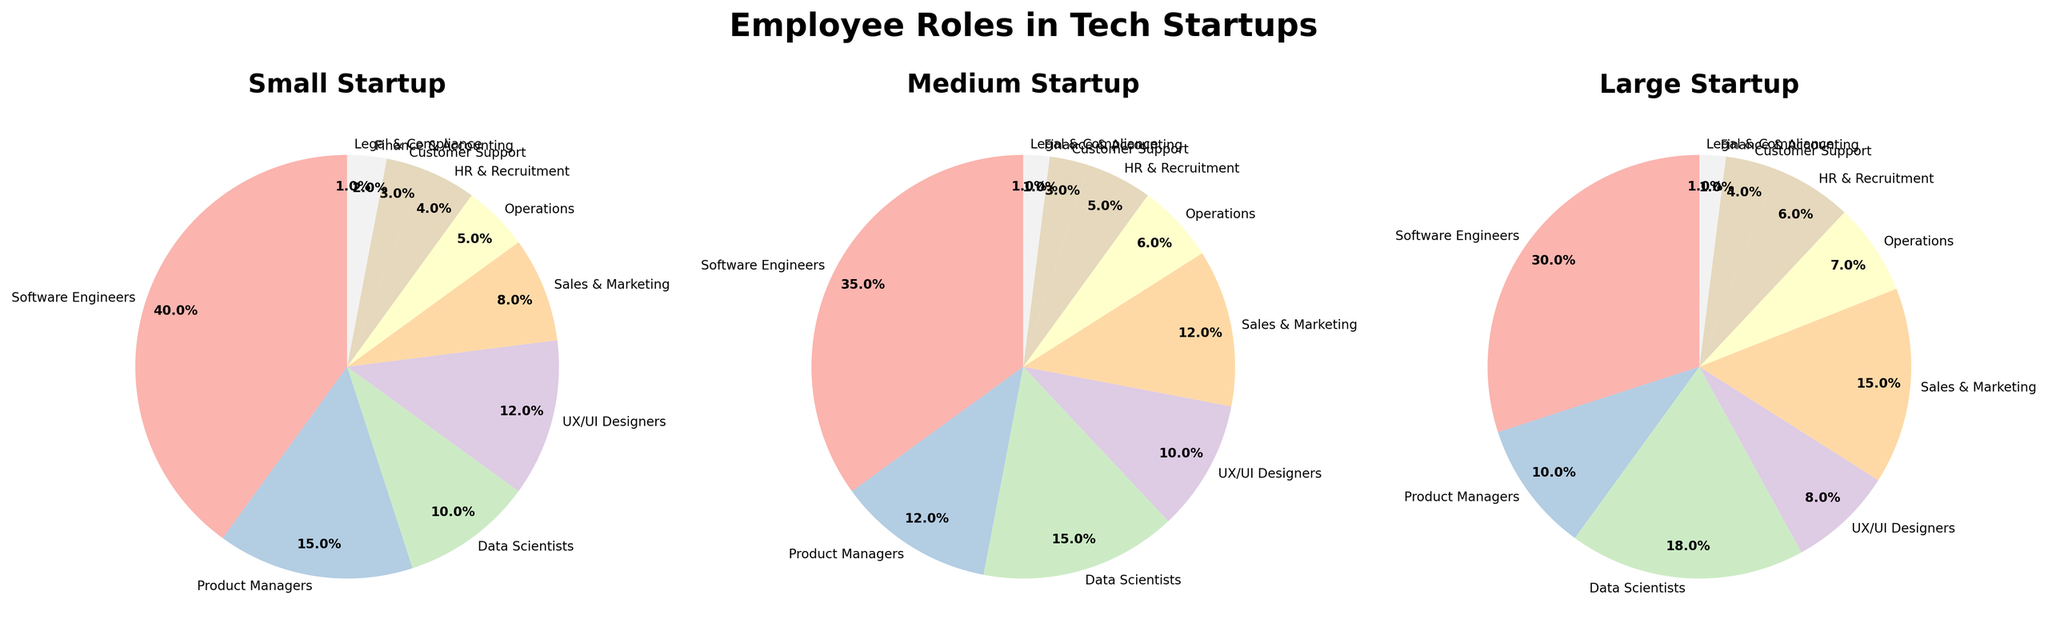What's the largest role in Small Startups? To find the largest role in Small Startups, we look at the sector of the pie chart with the largest proportion. In this chart, Software Engineers have the largest proportion among all roles.
Answer: Software Engineers What's the combined percentage of Product Managers and Data Scientists in Medium Startups? To find the combined percentage, look at the respective sectors in the pie chart for Medium Startups. Product Managers and Data Scientists have percentages of 12% and 15%, respectively. Adding these gives 12% + 15% = 27%.
Answer: 27% Which role is more prevalent in Large Startups compared to Small Startups? We need to compare the percentages of roles in Large Startups to those in Small Startups. Sales & Marketing as well as Data Scientists have higher percentages in Large Startups compared to Small Startups.
Answer: Sales & Marketing, Data Scientists Among UX/UI Designers, Operations, and HR & Recruitment in Small Startups, which has the smallest percentage? Look at the pie chart for Small Startups and identify the sectors for UX/UI Designers, Operations, and HR & Recruitment. UX/UI Designers have a percentage of 12%, Operations 5%, and HR & Recruitment 4%. Hence, HR & Recruitment has the smallest percentage.
Answer: HR & Recruitment What is the difference in percentage of Software Engineers between Small and Medium Startups? From the pie charts, Software Engineers occupy 40% in Small Startups and 35% in Medium Startups. The difference is 40% - 35% = 5%.
Answer: 5% Compare the proportion of Customer Support roles in all three startup sizes. Which startup has the lowest and which has the highest? In the pie charts, Customer Support has the following percentages: Small Startups - 3%, Medium Startups - 3%, Large Startups - 4%. Small and Medium Startups have the lowest proportion while Large Startups have the highest.
Answer: Lowest: Small & Medium, Highest: Large If you sum up the percentages of Data Scientists and UX/UI Designers in Medium Startups, would it exceed that of Software Engineers in Large Startups? Data Scientists in Medium Startups have 15% and UX/UI Designers have 10%; summing these gives 15% + 10% = 25%. Software Engineers in Large Startups have 30%. Since 25% < 30%, it does not exceed.
Answer: No What role has the same percentage across all startup types? From the pie charts, Legal & Compliance shows consistently 1% for Small, Medium, and Large Startups.
Answer: Legal & Compliance How does the percentage of Sales & Marketing roles compare between Small and Large Startups? Compare the sectors of the pie charts for Small and Large Startups. Sales & Marketing roles have 8% in Small Startups and 15% in Large Startups. Sales & Marketing is more prevalent in Large Startups.
Answer: More prevalent in Large Startups What's the total percentage of Finance & Accounting roles across all startup types? For Finance & Accounting, the percentages are: Small Startups - 2%, Medium Startups - 1%, Large Startups - 1%. Adding these yields 2% + 1% + 1% = 4%.
Answer: 4% 